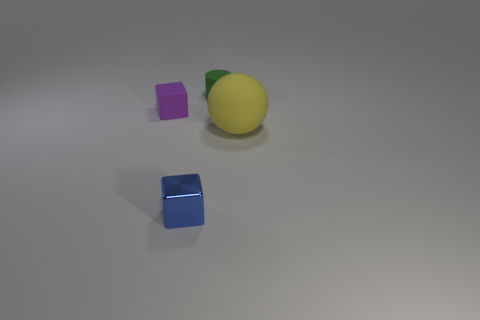How many objects are in front of the rubber sphere and to the right of the tiny green thing? From the perspective of the camera, there appears to be no objects directly in front of the yellow rubber sphere and to the right of the small green object. However, considering the spatial arrangement of all visible objects, it's possible to interpret the positioning differently based on one's point of reference. 